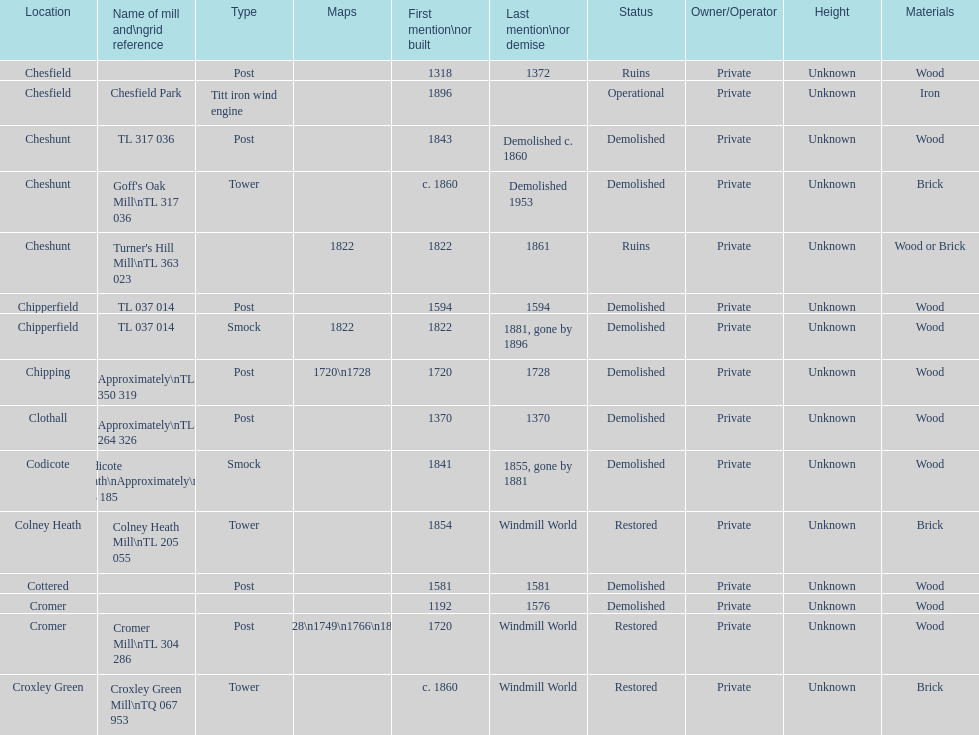How many mills were built or first mentioned after 1800? 8. 